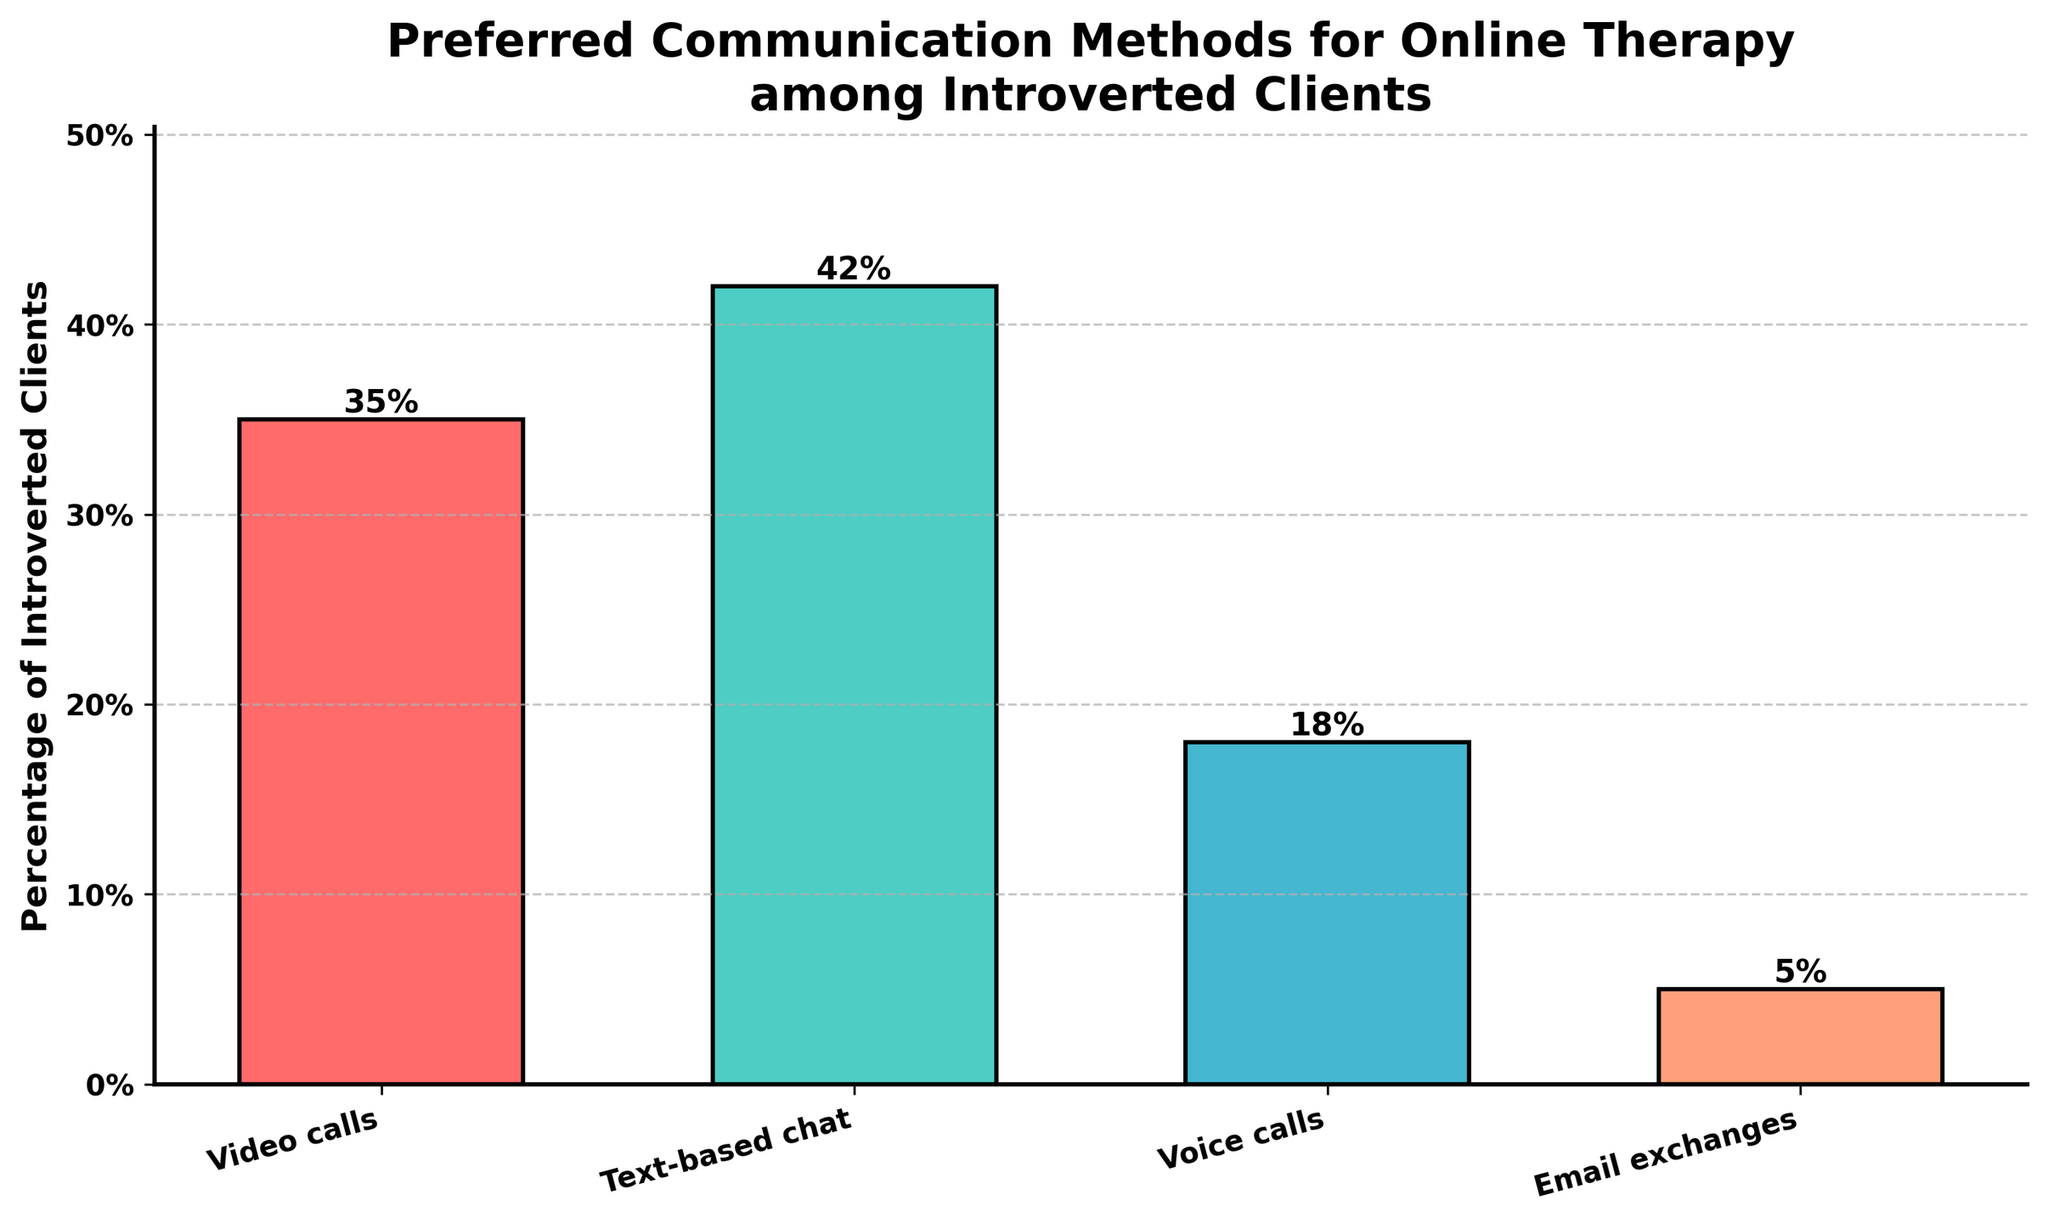What's the most preferred communication method for online therapy among introverted clients? The tallest bar in the chart represents the text-based chat method. Its height is the greatest among all communication methods, showing a percentage of 42%.
Answer: Text-based chat Which communication method has the least preference among introverted clients? The shortest bar in the chart represents email exchanges. Its height is the smallest, showing a percentage of 5%.
Answer: Email exchanges What is the difference in preference between video calls and voice calls? To find the difference, we subtract the percentage of voice calls (18%) from the percentage of video calls (35%). 35% - 18% = 17%.
Answer: 17% What percentage of introverted clients prefer voice calls over email exchanges? To determine this, subtract the preference for email exchanges (5%) from the preference for voice calls (18%). 18% - 5% = 13%.
Answer: 13% What is the combined preference percentage for video calls and text-based chat? We add the percentages for video calls (35%) and text-based chat (42%). 35% + 42% = 77%.
Answer: 77% Which communication method has a greater preference, voice calls or email exchanges, and by how much? Voice calls have a greater preference than email exchanges. Subtract the percentage of email exchanges (5%) from the percentage of voice calls (18%). 18% - 5% = 13%.
Answer: Voice calls, 13% What is the average preference percentage for all communication methods listed? To find the average, add all the percentages and divide by the number of methods. (35% + 42% + 18% + 5%) / 4 = 100% / 4 = 25%.
Answer: 25% What is the visual color used to represent the method with the highest preference percentage? The bar representing text-based chat, which has the highest preference percentage (42%), is colored green.
Answer: Green Which communication method has a preference percentage that is more than double that of email exchanges? To determine this, compare the percentages to see which are more than twice email exchanges (5%). Both video calls (35%) and text-based chat (42%) are greater than 10%.
Answer: Video calls, Text-based chat 